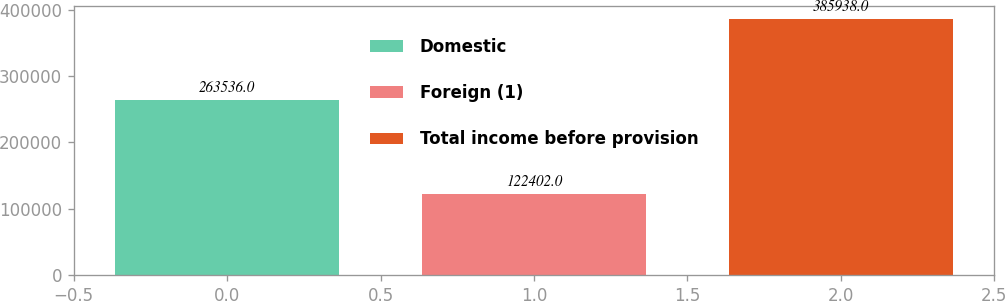Convert chart. <chart><loc_0><loc_0><loc_500><loc_500><bar_chart><fcel>Domestic<fcel>Foreign (1)<fcel>Total income before provision<nl><fcel>263536<fcel>122402<fcel>385938<nl></chart> 